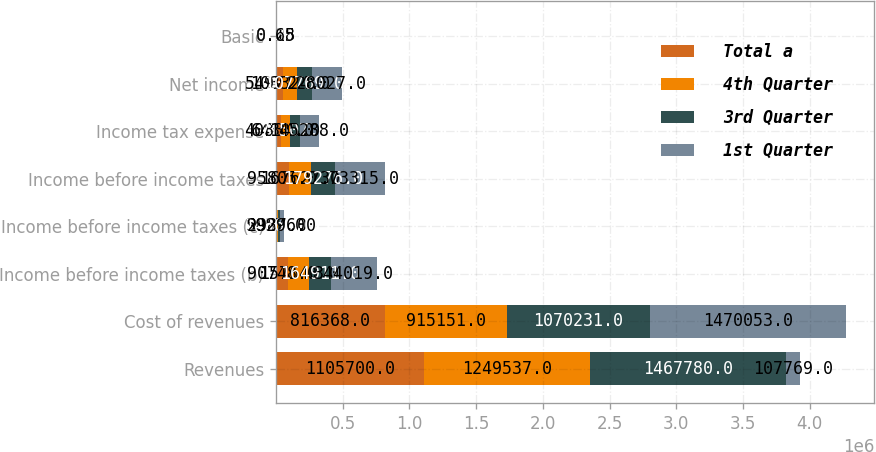Convert chart to OTSL. <chart><loc_0><loc_0><loc_500><loc_500><stacked_bar_chart><ecel><fcel>Revenues<fcel>Cost of revenues<fcel>Income before income taxes (b)<fcel>Income before income taxes (c)<fcel>Income before income taxes<fcel>Income tax expense<fcel>Net income<fcel>Basic<nl><fcel>Total a<fcel>1.1057e+06<fcel>816368<fcel>90748<fcel>5057<fcel>95805<fcel>40834<fcel>54971<fcel>0.15<nl><fcel>4th Quarter<fcel>1.24954e+06<fcel>915151<fcel>157640<fcel>9987<fcel>167627<fcel>64303<fcel>103324<fcel>0.28<nl><fcel>3rd Quarter<fcel>1.46778e+06<fcel>1.07023e+06<fcel>164911<fcel>14365<fcel>179276<fcel>71507<fcel>107769<fcel>0.31<nl><fcel>1st Quarter<fcel>107769<fcel>1.47005e+06<fcel>344019<fcel>29296<fcel>373315<fcel>145288<fcel>228027<fcel>0.65<nl></chart> 